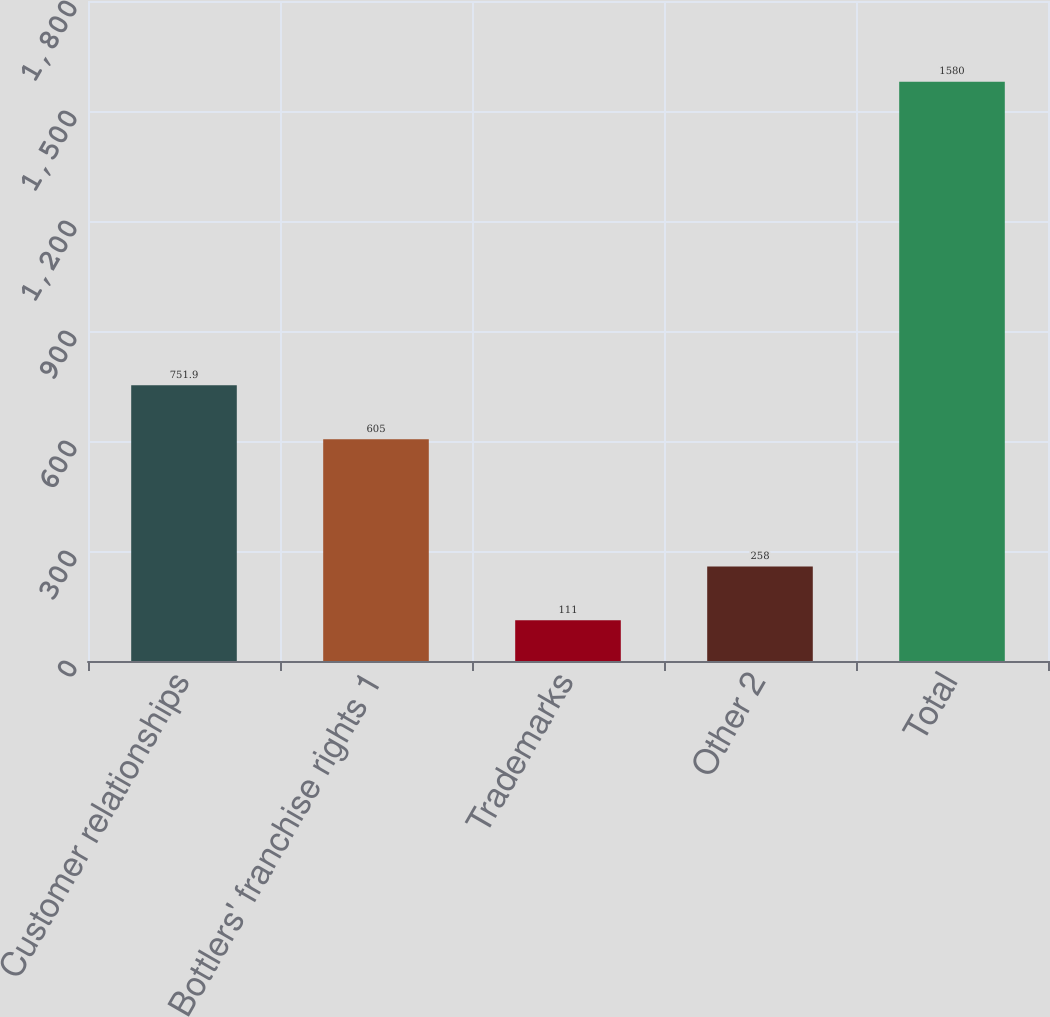Convert chart. <chart><loc_0><loc_0><loc_500><loc_500><bar_chart><fcel>Customer relationships<fcel>Bottlers' franchise rights 1<fcel>Trademarks<fcel>Other 2<fcel>Total<nl><fcel>751.9<fcel>605<fcel>111<fcel>258<fcel>1580<nl></chart> 